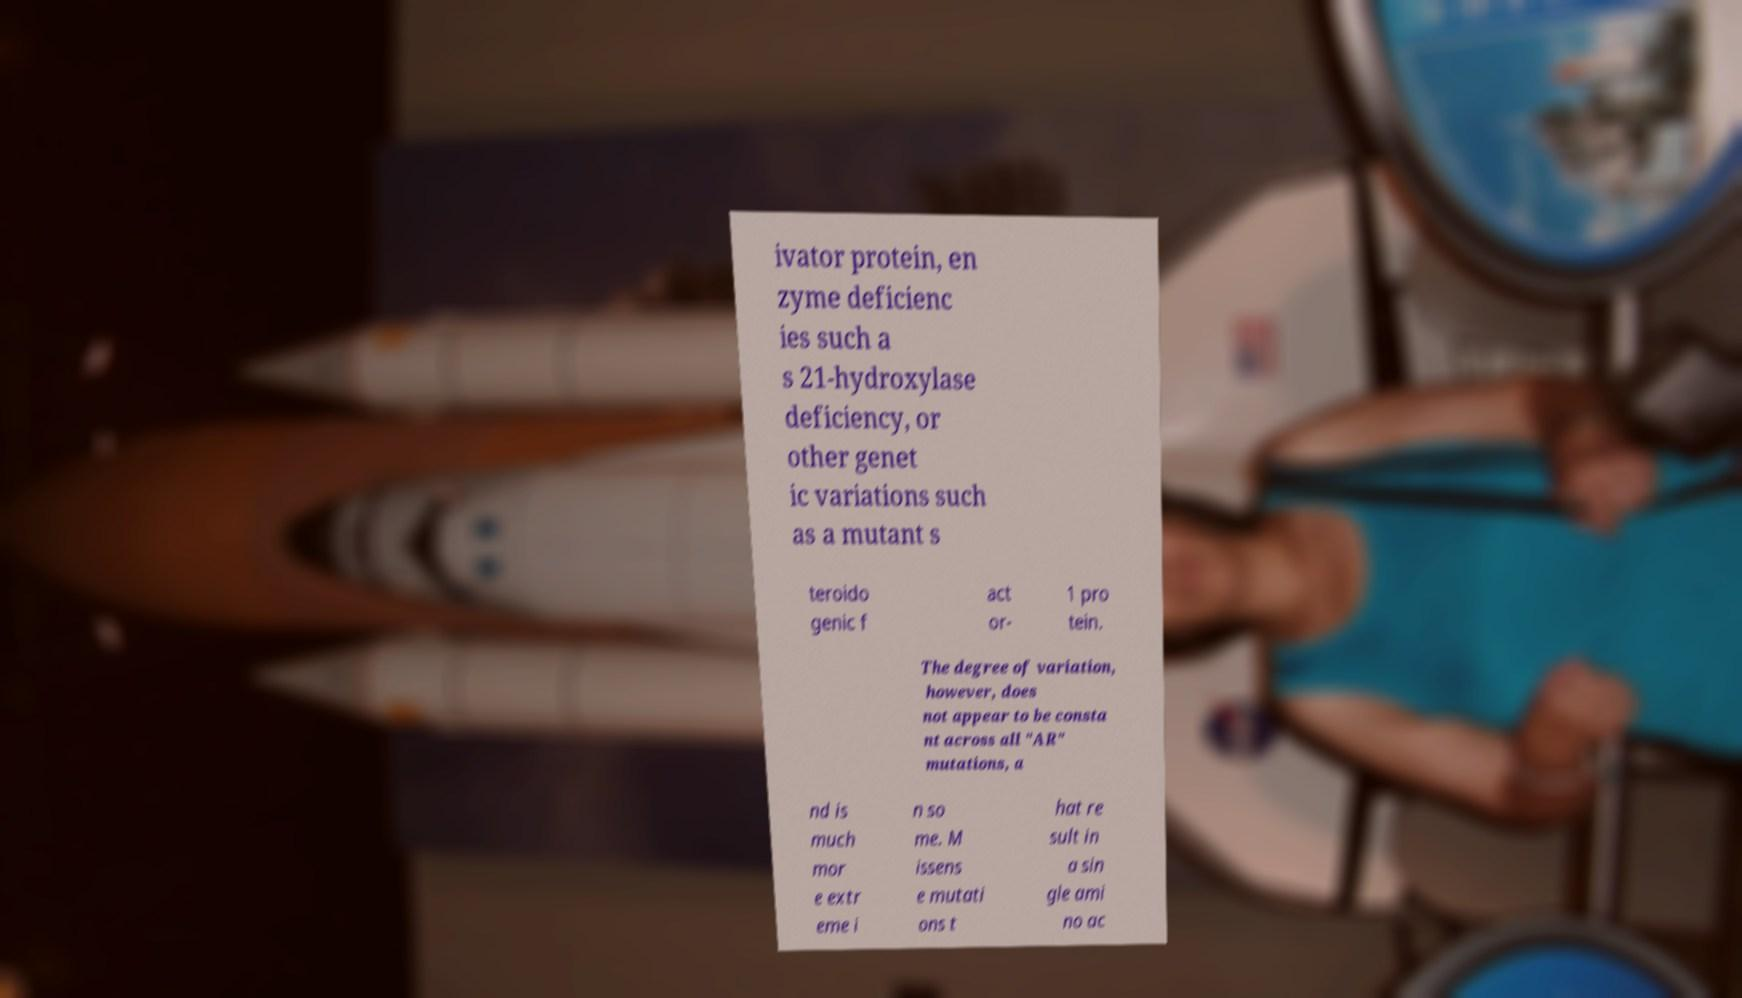Please identify and transcribe the text found in this image. ivator protein, en zyme deficienc ies such a s 21-hydroxylase deficiency, or other genet ic variations such as a mutant s teroido genic f act or- 1 pro tein. The degree of variation, however, does not appear to be consta nt across all "AR" mutations, a nd is much mor e extr eme i n so me. M issens e mutati ons t hat re sult in a sin gle ami no ac 